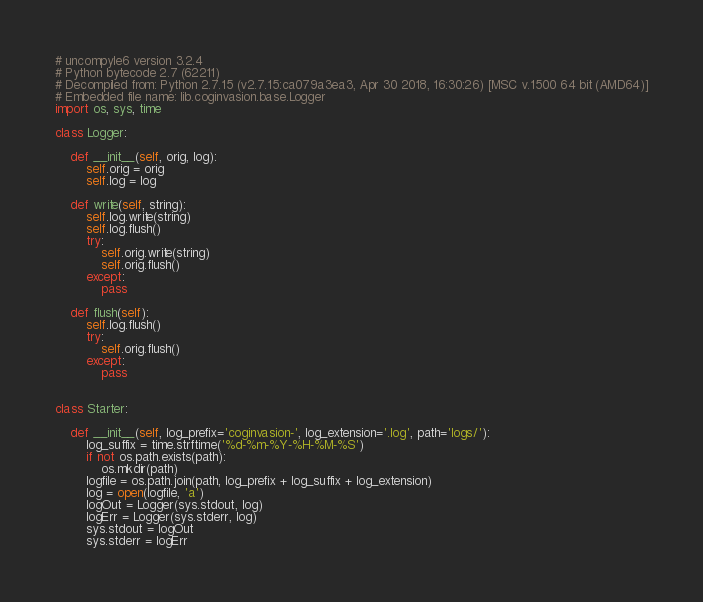Convert code to text. <code><loc_0><loc_0><loc_500><loc_500><_Python_># uncompyle6 version 3.2.4
# Python bytecode 2.7 (62211)
# Decompiled from: Python 2.7.15 (v2.7.15:ca079a3ea3, Apr 30 2018, 16:30:26) [MSC v.1500 64 bit (AMD64)]
# Embedded file name: lib.coginvasion.base.Logger
import os, sys, time

class Logger:

    def __init__(self, orig, log):
        self.orig = orig
        self.log = log

    def write(self, string):
        self.log.write(string)
        self.log.flush()
        try:
            self.orig.write(string)
            self.orig.flush()
        except:
            pass

    def flush(self):
        self.log.flush()
        try:
            self.orig.flush()
        except:
            pass


class Starter:

    def __init__(self, log_prefix='coginvasion-', log_extension='.log', path='logs/'):
        log_suffix = time.strftime('%d-%m-%Y-%H-%M-%S')
        if not os.path.exists(path):
            os.mkdir(path)
        logfile = os.path.join(path, log_prefix + log_suffix + log_extension)
        log = open(logfile, 'a')
        logOut = Logger(sys.stdout, log)
        logErr = Logger(sys.stderr, log)
        sys.stdout = logOut
        sys.stderr = logErr</code> 